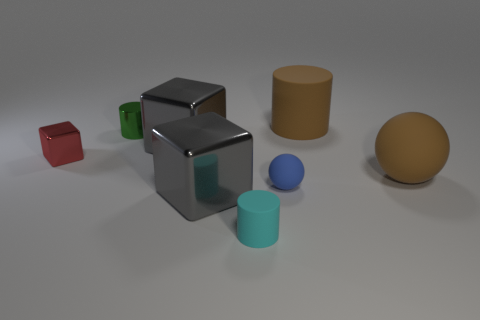Is the cyan cylinder made of the same material as the brown thing that is in front of the small red metal thing?
Provide a short and direct response. Yes. Is the shape of the brown rubber thing that is in front of the green object the same as  the small blue rubber thing?
Your answer should be compact. Yes. How many big gray blocks have the same material as the large brown ball?
Your response must be concise. 0. What number of objects are tiny metallic objects left of the small green metal object or large shiny objects?
Make the answer very short. 3. What size is the green object?
Offer a very short reply. Small. What is the large cylinder behind the big gray metallic block that is in front of the large ball made of?
Your response must be concise. Rubber. Does the matte cylinder to the right of the cyan rubber cylinder have the same size as the red cube?
Provide a succinct answer. No. Are there any large rubber cylinders of the same color as the big ball?
Your answer should be very brief. Yes. What number of things are either big gray cubes behind the red thing or objects behind the brown ball?
Give a very brief answer. 4. Is the color of the small metallic block the same as the big rubber cylinder?
Provide a succinct answer. No. 